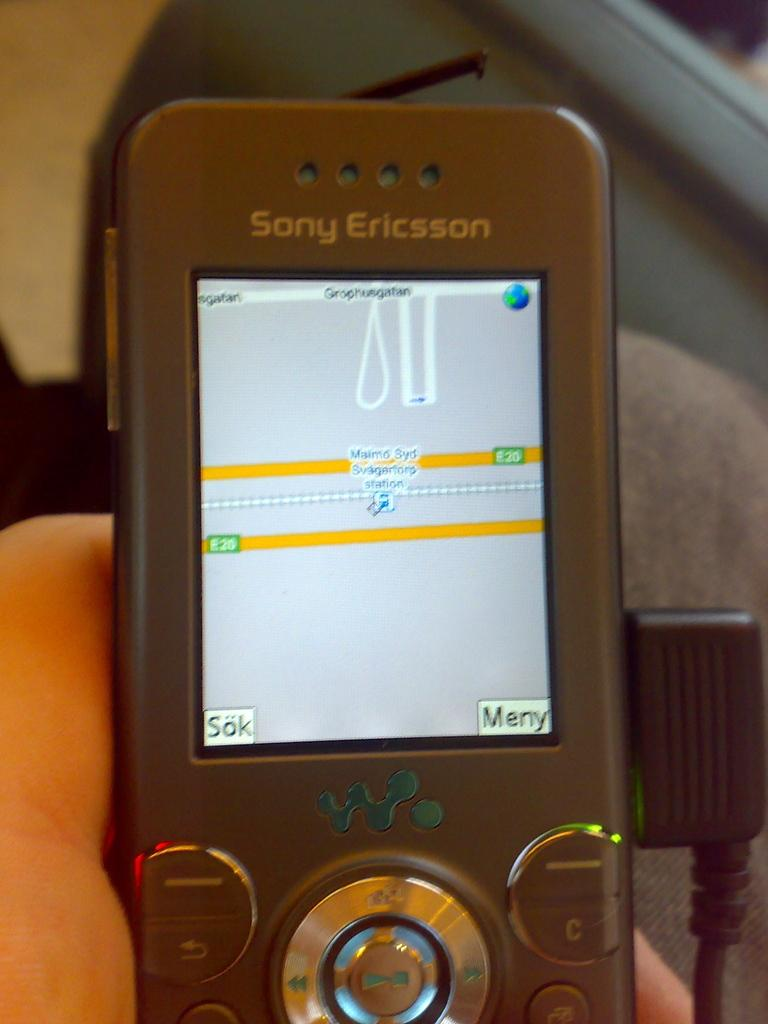What can be seen in the image that belongs to a person? There is a person's hand in the image. What is the hand holding? The hand is holding a mobile phone. What is displayed on the mobile phone's screen? The mobile phone's screen displays a map. How is the mobile phone being powered in the image? The mobile phone is connected to a charger. What type of meat is being cooked on the stove in the image? There is no stove or meat present in the image; it only features a person's hand holding a mobile phone. 